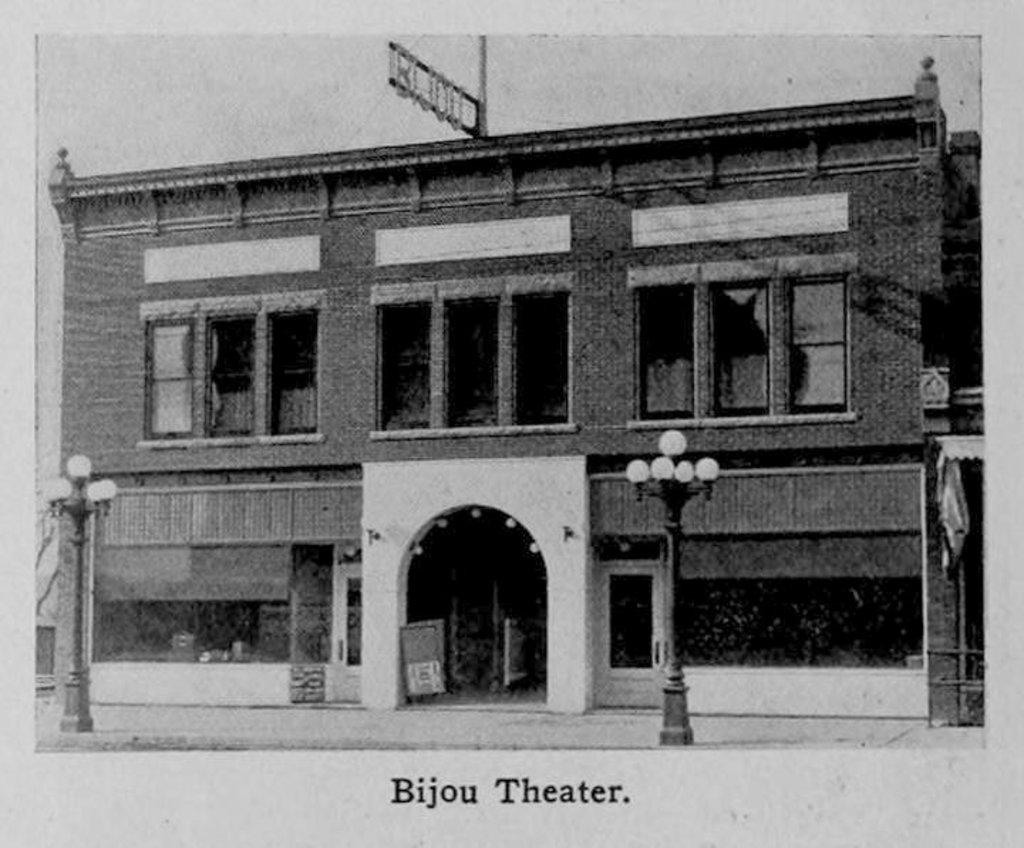What is the color scheme of the image? The image is black and white. What is the main subject in the center of the image? There is a building in the center of the image. What other objects can be seen in the image? There are poles and lights in the image. Is there any text present in the image? Yes, there is text at the bottom of the image. Can you see the ocean in the image? No, there is no ocean present in the image. What type of cable is connected to the building in the image? There is no cable connected to the building in the image. 